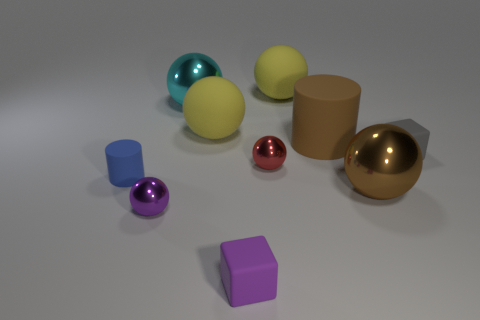Subtract all small red metal spheres. How many spheres are left? 5 Add 9 green rubber things. How many green rubber things exist? 9 Subtract all purple cubes. How many cubes are left? 1 Subtract 1 red balls. How many objects are left? 9 Subtract all cylinders. How many objects are left? 8 Subtract 4 balls. How many balls are left? 2 Subtract all blue cubes. Subtract all purple spheres. How many cubes are left? 2 Subtract all cyan spheres. How many red cylinders are left? 0 Subtract all gray things. Subtract all yellow spheres. How many objects are left? 7 Add 9 tiny red spheres. How many tiny red spheres are left? 10 